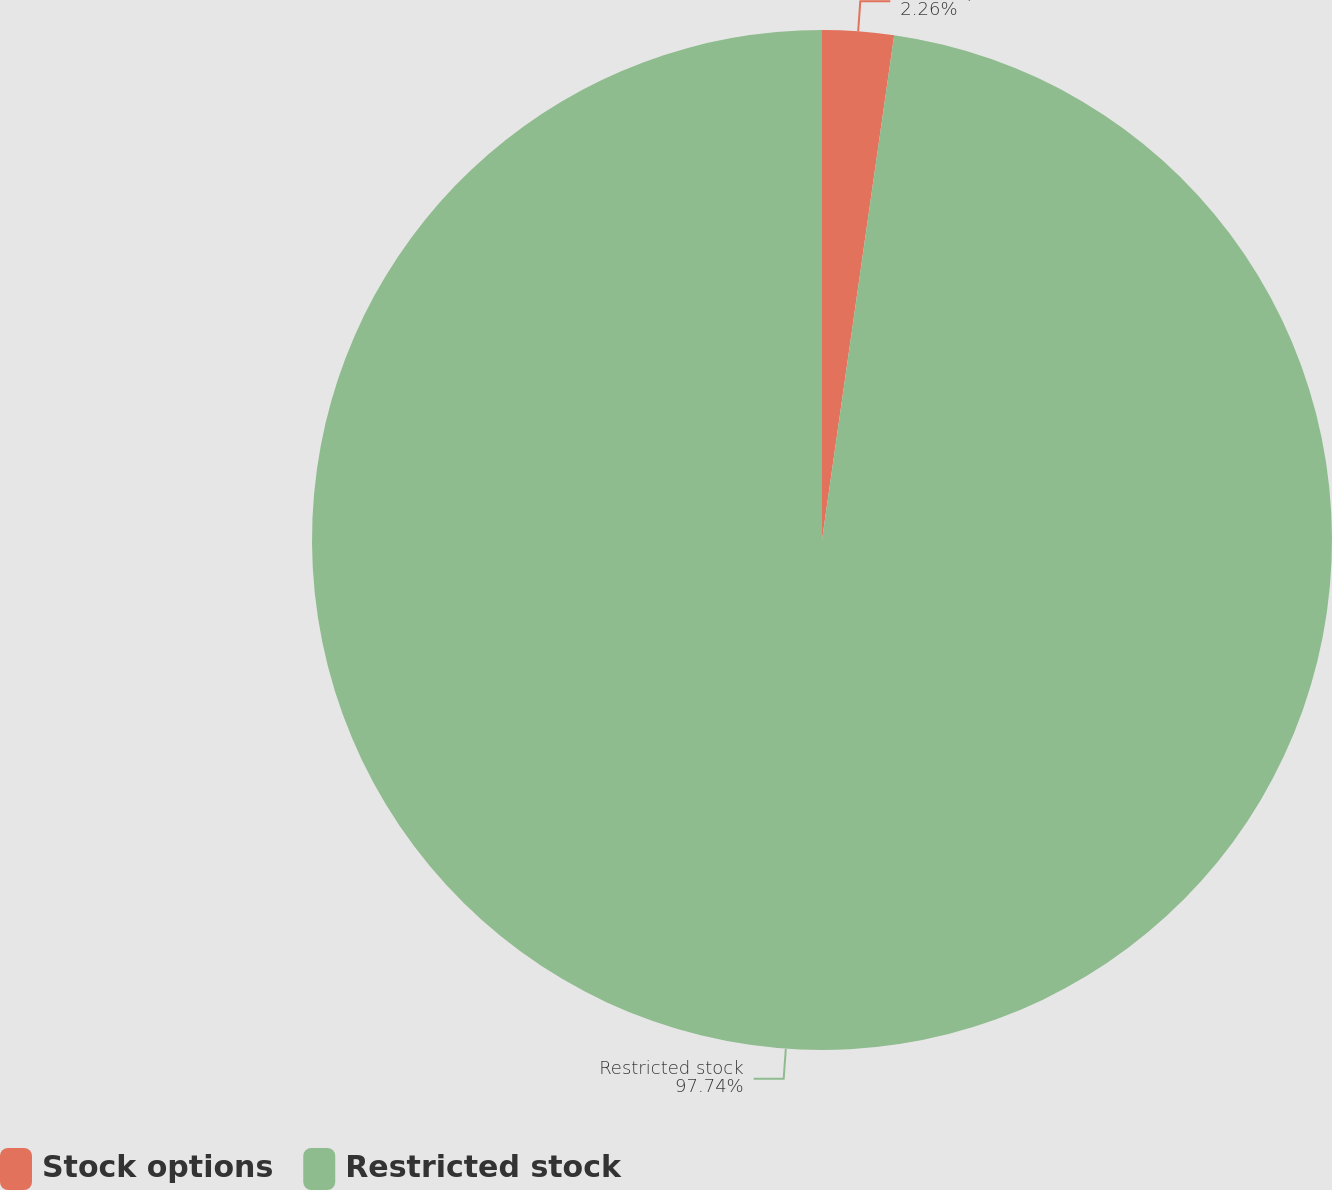<chart> <loc_0><loc_0><loc_500><loc_500><pie_chart><fcel>Stock options<fcel>Restricted stock<nl><fcel>2.26%<fcel>97.74%<nl></chart> 